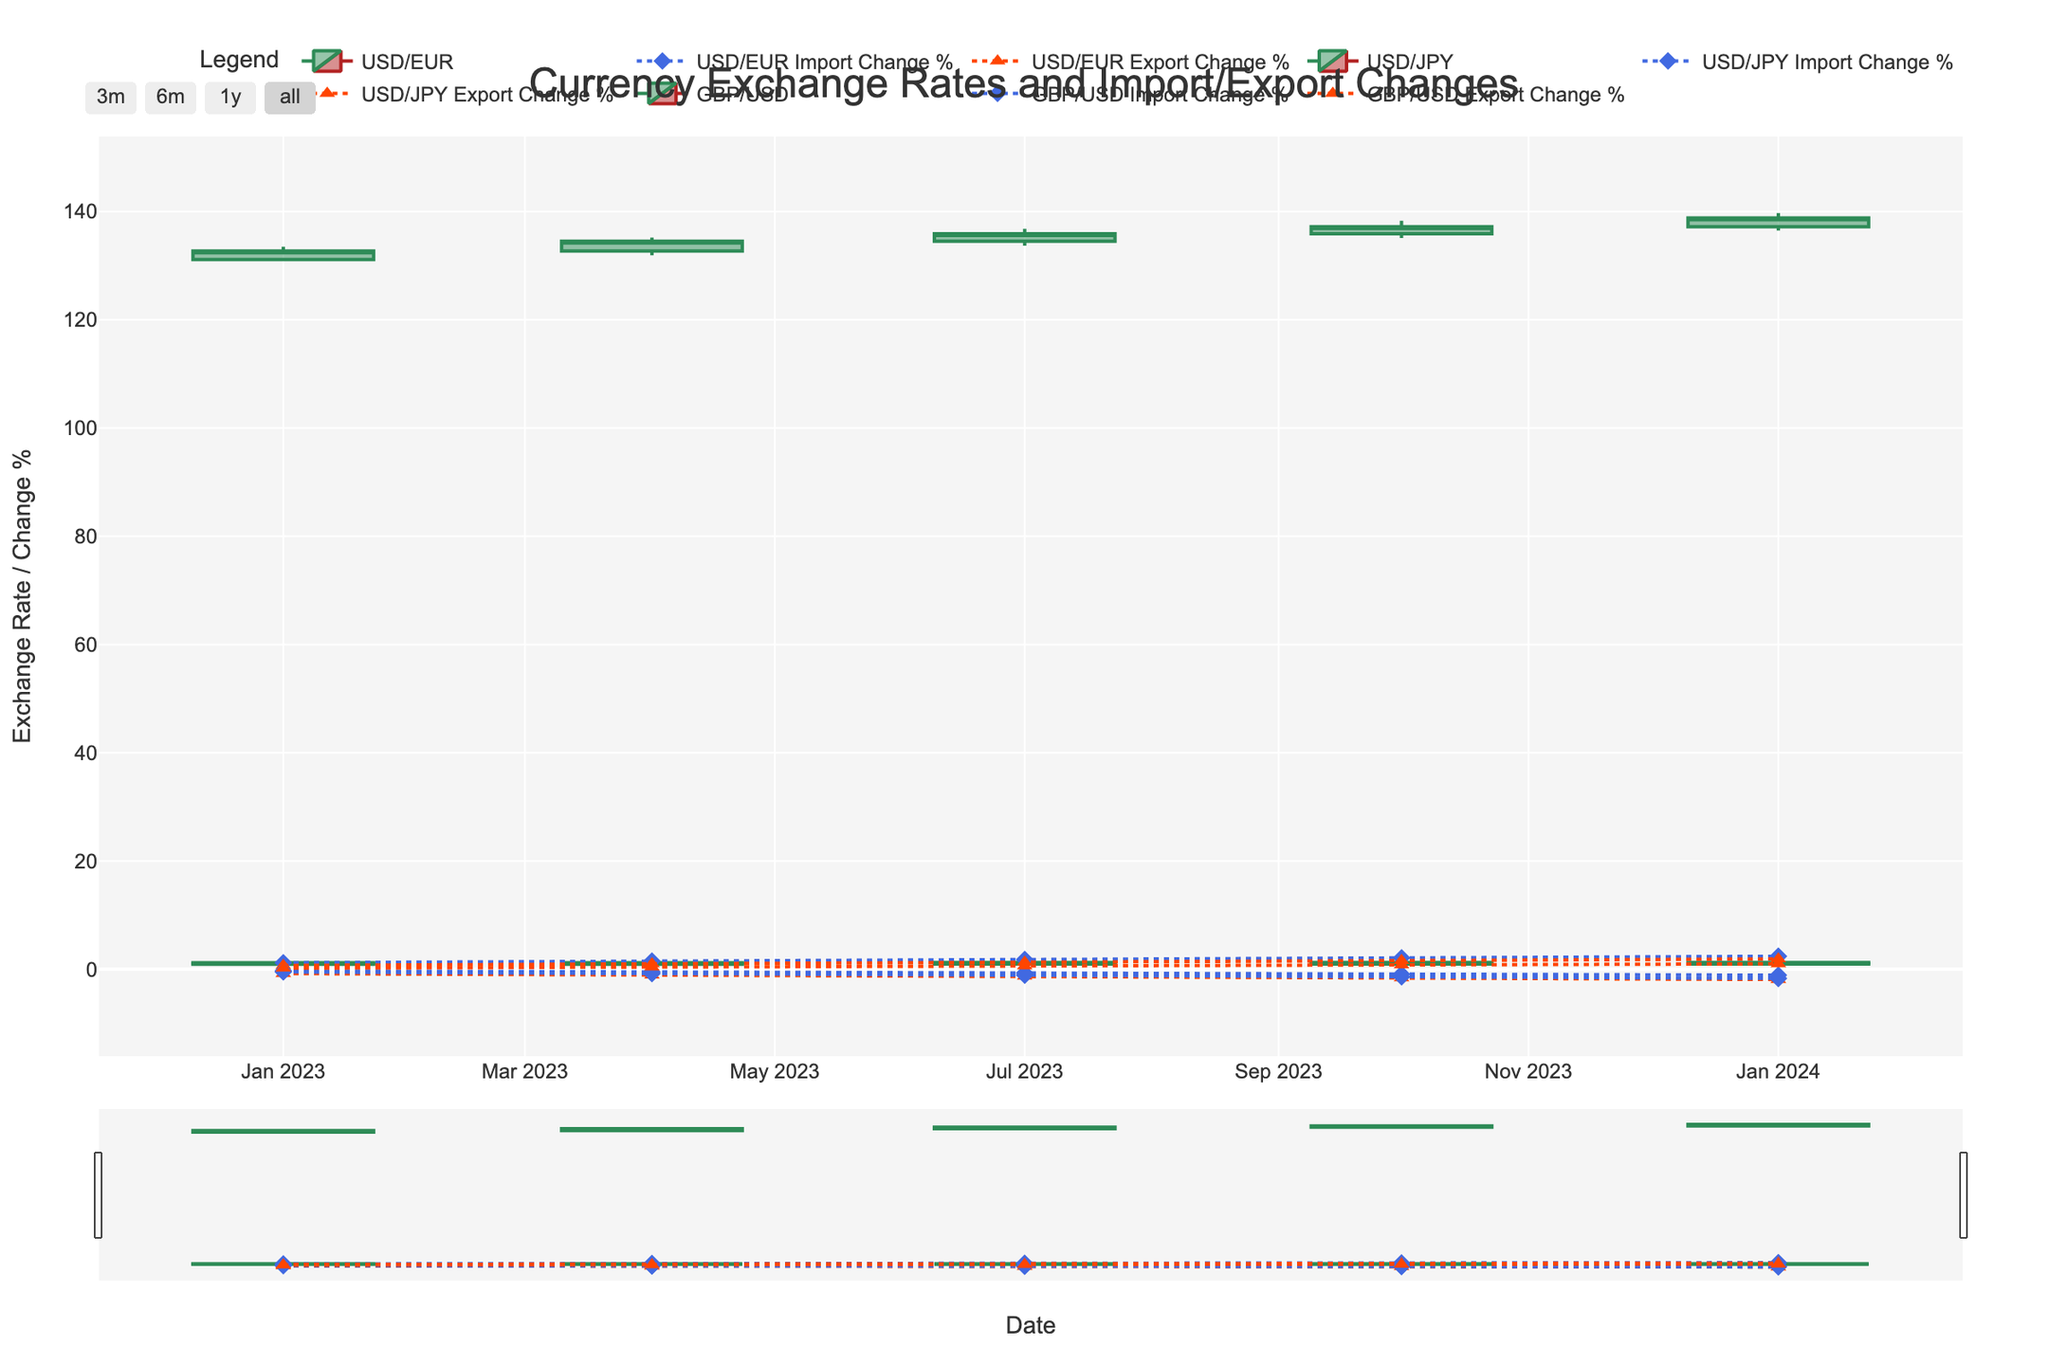What is the opening exchange rate for the USD/EUR currency pair on January 1, 2023? To find the opening exchange rate for USD/EUR on January 1, 2023, look at the corresponding 'Open' value for that date on the OHLC chart.
Answer: 0.9372 Which currency pair shows the highest closing rate on October 1, 2023? Compare the 'Close' values for each currency pair on the OHLC chart for October 1, 2023. The USD/JPY pair has the highest closing rate.
Answer: USD/JPY How did the import percentage change for GBP/USD from January 1, 2023, to January 1, 2024? Observe the 'Import_Change%' markers for GBP/USD on January 1, 2023, and January 1, 2024, and calculate the difference. The change is from -0.3% to -1.1%.
Answer: -0.8% Which quarter exhibits the greatest volatility in the USD/JPY exchange rate in 2023? Volatility can be inferred from the size of the candlesticks (range between 'High' and 'Low'). Compare the ranges for each quarter: Q1, Q2, Q3, and Q4. Q4 (October) shows the greatest range (High: 138.30 - Low: 135.10 = 3.20).
Answer: October (Q4) How does the export change percentage for USD/EUR trend over the year 2023? Check the 'Export_Change%' markers for USD/EUR across the dates in 2023 and observe the pattern. The trend shows a consistent decline: -0.8%, -1.1%, -1.3%, -1.6%.
Answer: Declining trend What is the peak exchange rate for GBP/USD in 2023? Identify the highest 'High' value for GBP/USD in the dates of 2023 on the OHLC chart. The highest value is 1.2390 on October 1, 2023.
Answer: 1.2390 How much percentage change in imports occurred for USD/JPY from Q1 to Q3 of 2023? Calculate the difference between 'Import_Change%' on January 1, 2023, and July 1, 2023, for USD/JPY. The change from -0.5% to -1.1% equals a -0.6% change.
Answer: -0.6% Are the USD/EUR import and export changes positively or negatively correlated in 2023? Observe the 'Import_Change%' and 'Export_Change%' lines for USD/EUR. Both move in opposite directions over the dates in 2023, indicating a negative correlation.
Answer: Negatively correlated Which currency pair experienced the smallest low value on the entire chart? Compare the 'Low' values of all currency pairs across the entire dataset. The smallest value is for USD/JPY at 130.80 on January 1, 2023.
Answer: USD/JPY 